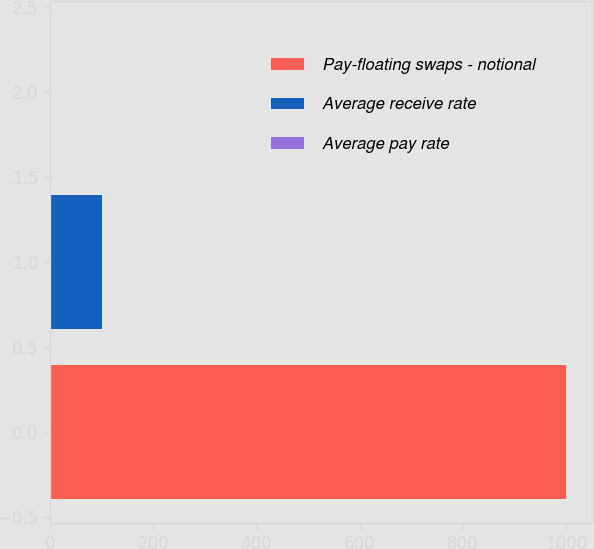Convert chart to OTSL. <chart><loc_0><loc_0><loc_500><loc_500><bar_chart><fcel>Pay-floating swaps - notional<fcel>Average receive rate<fcel>Average pay rate<nl><fcel>1000<fcel>101.44<fcel>1.6<nl></chart> 